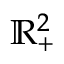<formula> <loc_0><loc_0><loc_500><loc_500>\mathbb { R } _ { + } ^ { 2 }</formula> 